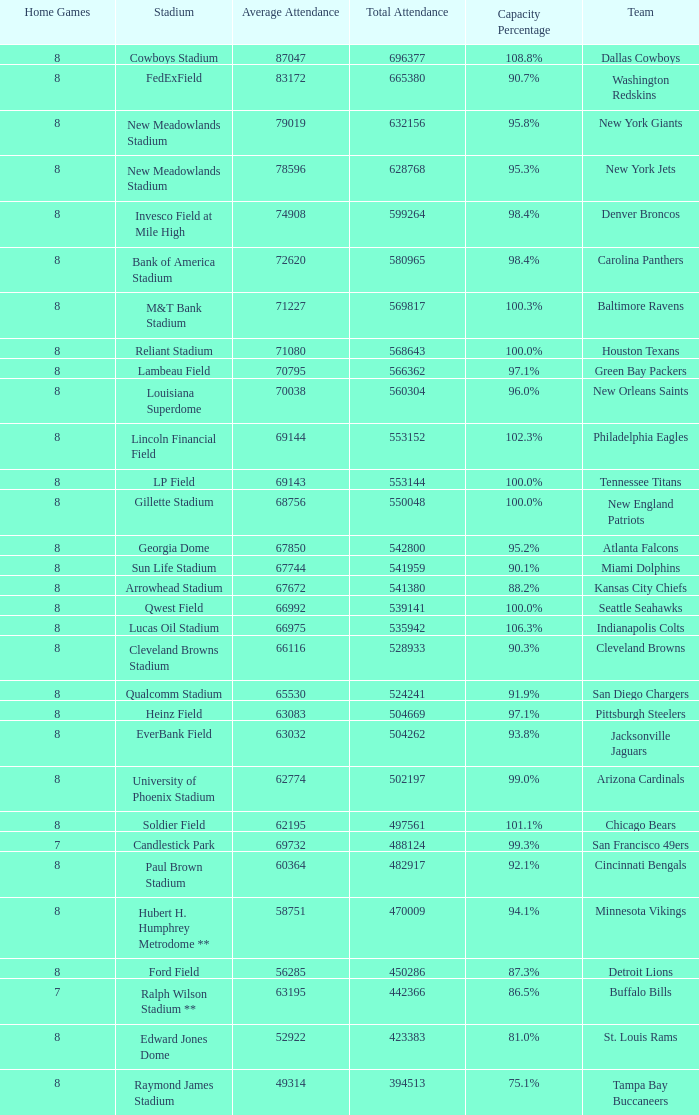What team had a capacity of 102.3%? Philadelphia Eagles. 